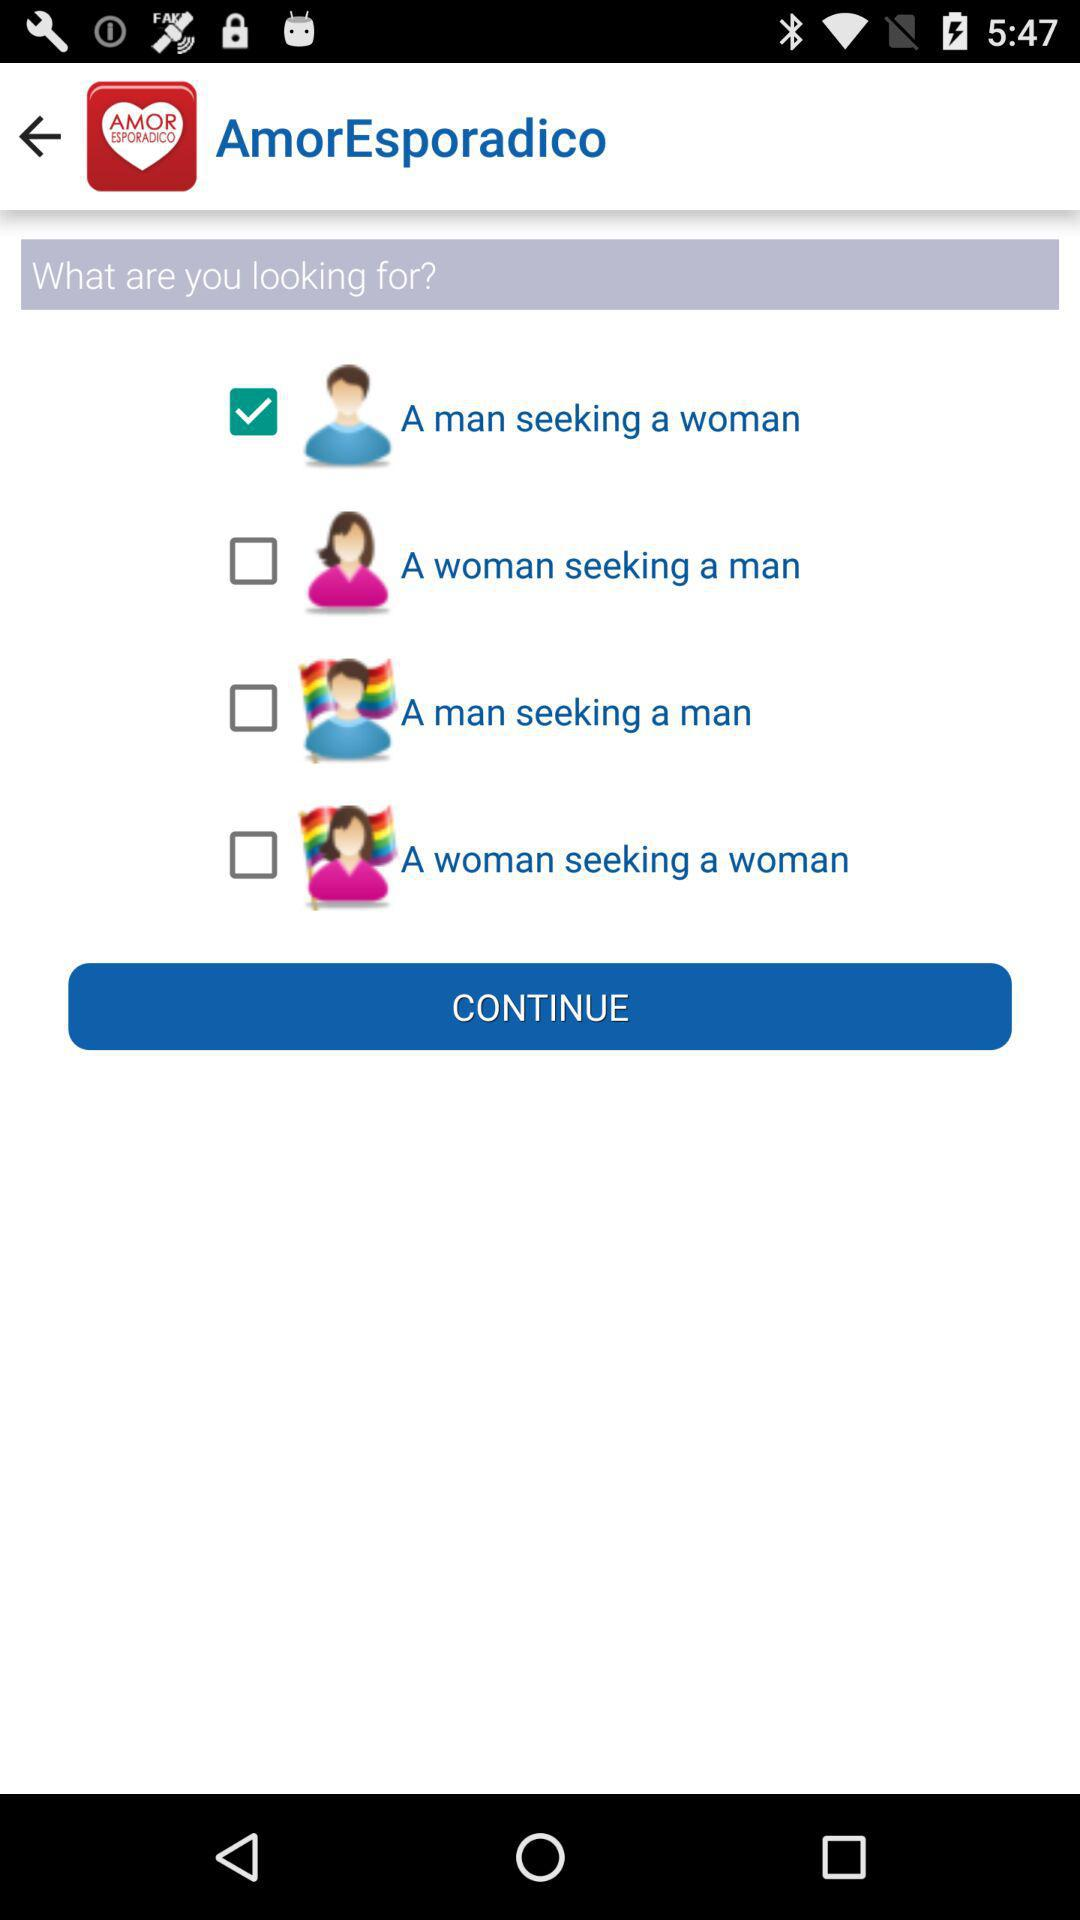How many options are there to choose from?
Answer the question using a single word or phrase. 4 